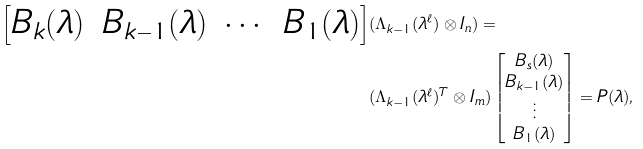Convert formula to latex. <formula><loc_0><loc_0><loc_500><loc_500>\begin{bmatrix} B _ { k } ( \lambda ) & B _ { k - 1 } ( \lambda ) & \cdots & B _ { 1 } ( \lambda ) \end{bmatrix} & ( \Lambda _ { k - 1 } ( \lambda ^ { \ell } ) \otimes I _ { n } ) = \\ & ( \Lambda _ { k - 1 } ( \lambda ^ { \ell } ) ^ { T } \otimes I _ { m } ) \begin{bmatrix} B _ { s } ( \lambda ) \\ B _ { k - 1 } ( \lambda ) \\ \vdots \\ B _ { 1 } ( \lambda ) \end{bmatrix} = P ( \lambda ) ,</formula> 